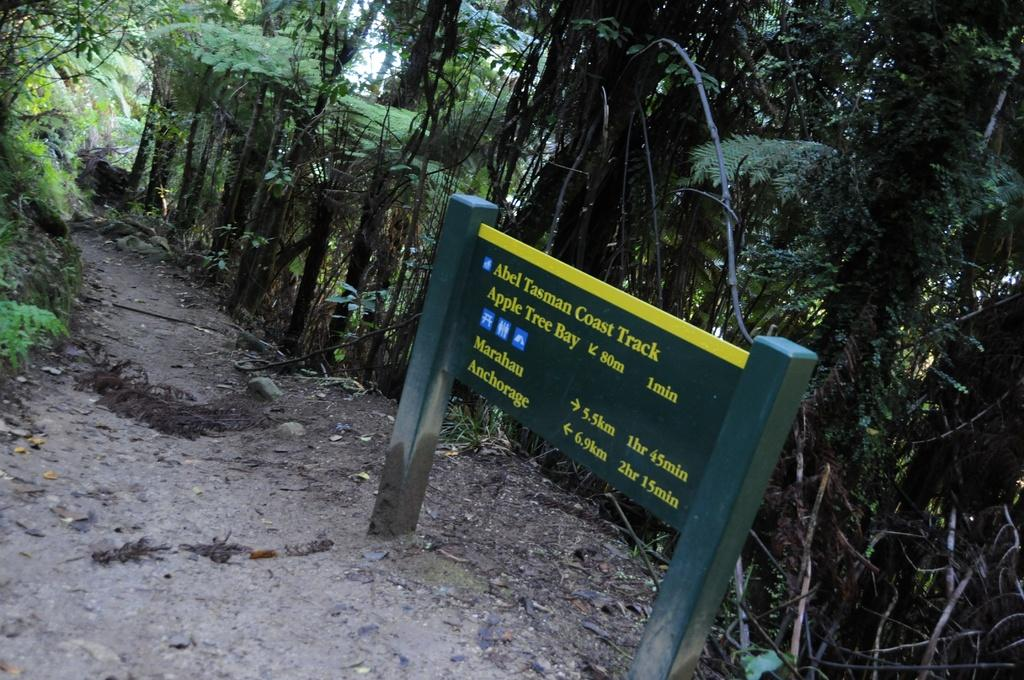What is the main object in the center of the image? There is a sign board in the center of the image. What can be seen in the background of the image? There are trees in the background of the image. What type of terrain is visible at the bottom of the image? There is sand at the bottom of the image. What type of toe is visible in the image? There are no toes visible in the image. What is the cause of the sign board in the image? The provided facts do not mention the cause or purpose of the sign board, so we cannot determine the reason for its presence in the image. 